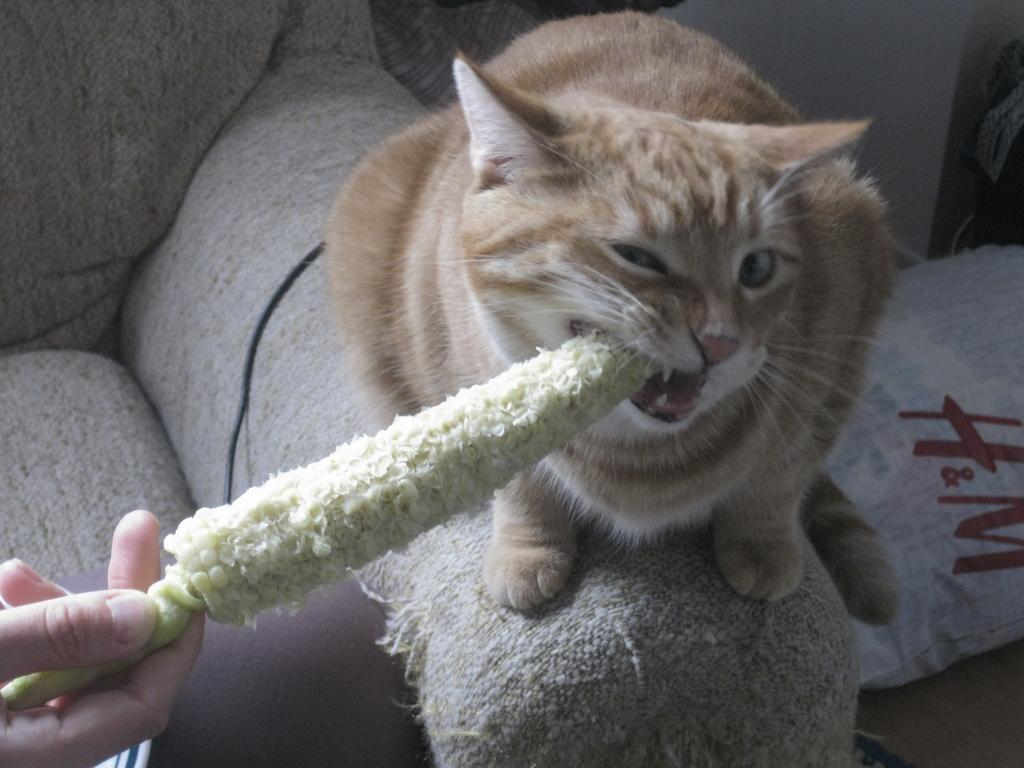What animal is sitting on the couch in the image? There is a cat sitting on a couch in the image. What is the person holding in the image? A person is holding a bare corn cob in the image. How much of the person is visible in the image? Only the person's hand is visible in the image. What else can be seen on the couch in the image? There is a cable on the couch in the image, as well as other unspecified things. What type of glove is the person wearing while holding the corn cob in the image? There is no glove visible in the image; only the person's hand is visible while holding the corn cob. 